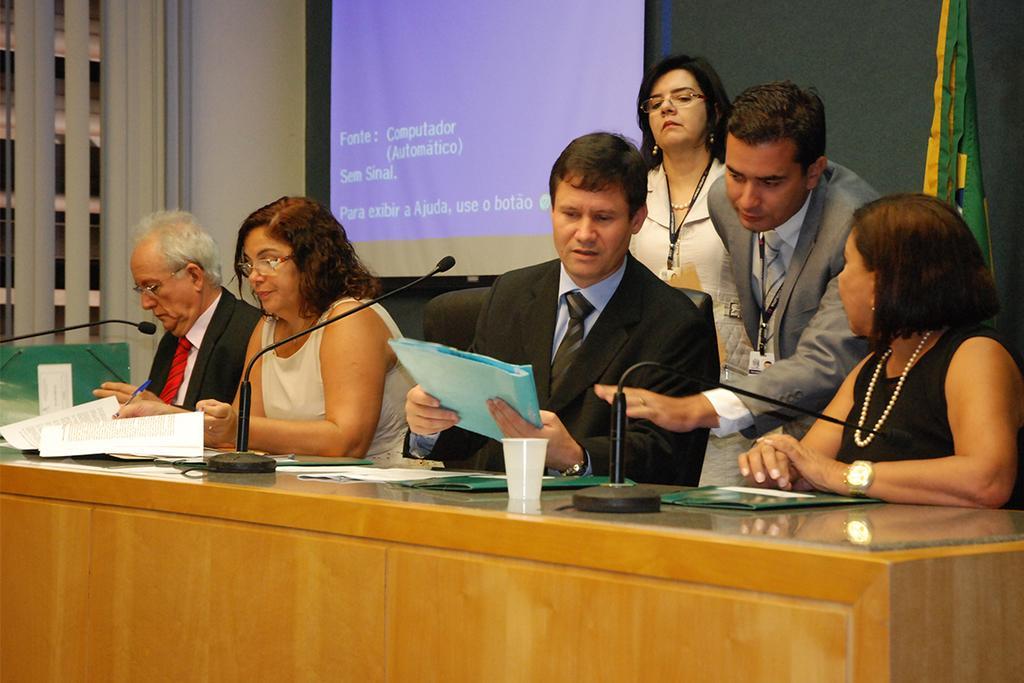Describe this image in one or two sentences. In this picture I can see couple of humans are standing and few people are siting on the chairs and I can see a glass, few microphones and papers on the table and a projector screen in the back and a flag on the right side of the picture. 